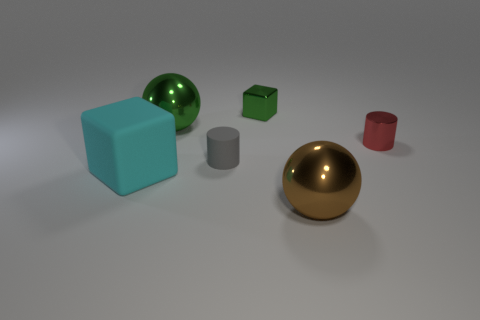The tiny green thing is what shape?
Keep it short and to the point. Cube. Is the cyan object made of the same material as the large brown ball?
Ensure brevity in your answer.  No. What number of objects are big shiny balls or large brown metallic spheres in front of the large green metallic ball?
Your response must be concise. 2. There is a thing that is the same color as the tiny metallic cube; what is its size?
Give a very brief answer. Large. There is a small thing on the right side of the green metal block; what shape is it?
Offer a terse response. Cylinder. Is the color of the ball behind the large cyan rubber object the same as the shiny cube?
Offer a very short reply. Yes. What material is the object that is the same color as the tiny block?
Your answer should be compact. Metal. There is a sphere behind the red shiny thing; is its size the same as the big cyan matte object?
Ensure brevity in your answer.  Yes. Is there a sphere that has the same color as the tiny shiny block?
Ensure brevity in your answer.  Yes. There is a ball on the left side of the brown metal thing; are there any green metallic balls to the right of it?
Your answer should be compact. No. 